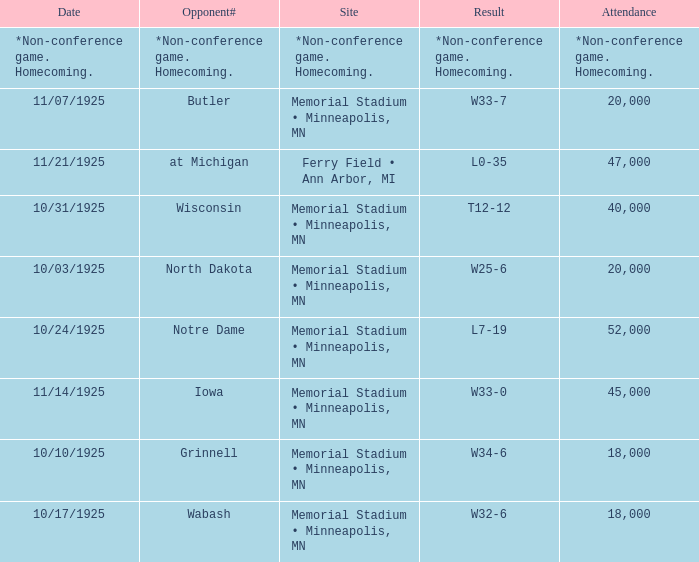Who was the opponent at the game attended by 45,000? Iowa. 